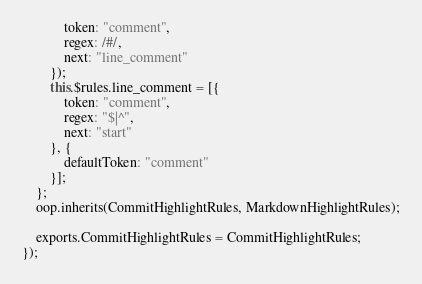<code> <loc_0><loc_0><loc_500><loc_500><_JavaScript_>            token: "comment",
            regex: /#/,
            next: "line_comment"
        });
        this.$rules.line_comment = [{
            token: "comment",
            regex: "$|^",
            next: "start"
        }, {
            defaultToken: "comment"
        }];
    };
    oop.inherits(CommitHighlightRules, MarkdownHighlightRules);

    exports.CommitHighlightRules = CommitHighlightRules;
});
</code> 